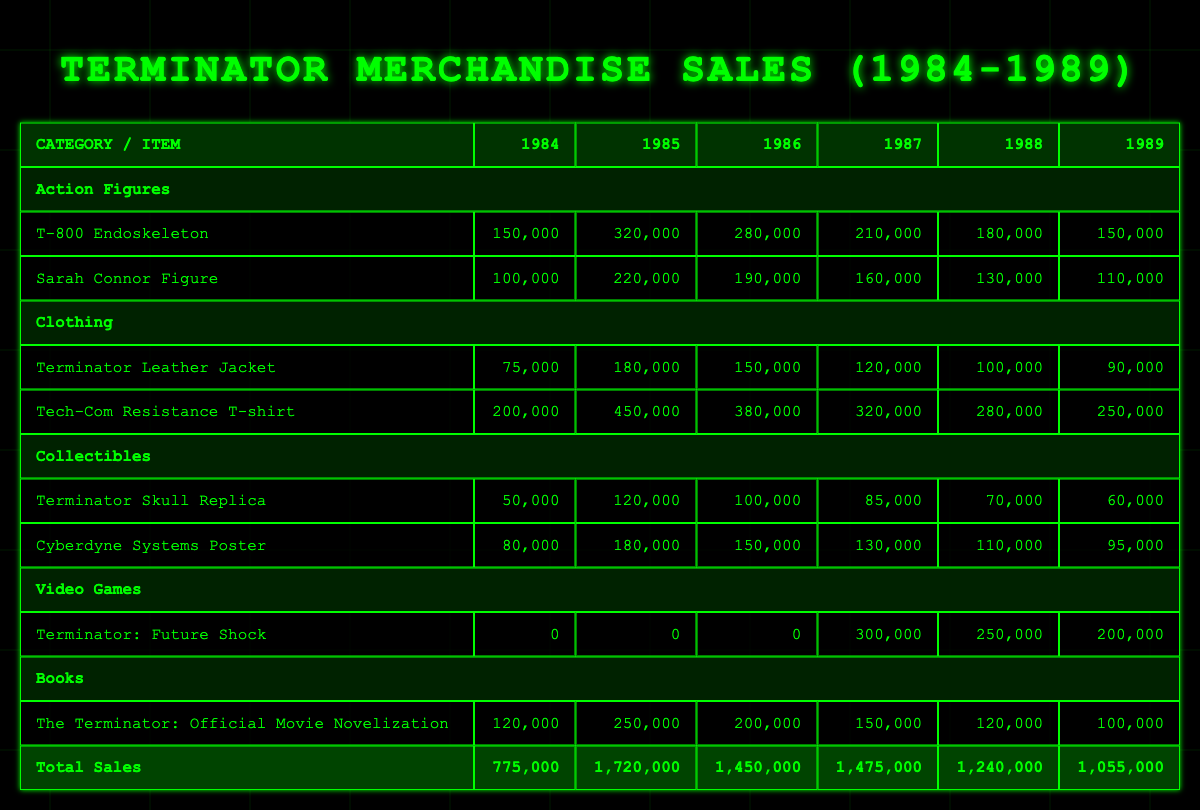What were the total sales for 1985? The total sales for 1985 can be found in the "Total Sales" row of the table. It shows 1,720,000 for that year.
Answer: 1,720,000 Which item had the highest sales in 1986? By examining the sales for each item in 1986, the "Tech-Com Resistance T-shirt" had the highest sales at 380,000.
Answer: Tech-Com Resistance T-shirt What is the difference in sales of the T-800 Endoskeleton between 1985 and 1989? The sales for the T-800 Endoskeleton in 1985 were 320,000, and in 1989 it was 150,000. The difference is 320,000 - 150,000 = 170,000.
Answer: 170,000 Did the sales of the Terminator Leather Jacket ever exceed 200,000? Checking the sales figures for the Terminator Leather Jacket, they all stay below 200,000, which confirms that the statement is false.
Answer: No What is the average sales of the Cyberdyne Systems Poster over the years? To find the average, sum the sales for each year: (80,000 + 180,000 + 150,000 + 130,000 + 110,000 + 95,000) = 745,000. Then divide by the number of years, which is 6: 745,000 / 6 = 124,166.67, rounded to 124,167.
Answer: 124,167 Which year showed the highest total merchandise sales? The highest total sales can be found in the "Total Sales" row. 1985 shows the maximum total sales at 1,720,000.
Answer: 1985 What are the total sales for action figures in 1987? By summarizing the sales for both action figures in 1987, T-800 Endoskeleton (210,000) + Sarah Connor Figure (160,000) gives a total of 370,000 for that category.
Answer: 370,000 Was the sales trend for the Tech-Com Resistance T-shirt increasing over its years? The sales for this item show an increase each year from 200,000 in 1984 to 450,000 in 1985 and continues to decrease after that, indicating the trend was not consistently increasing.
Answer: No How much did the sales of video games total from 1984 to 1989? The only video game listed is Terminator: Future Shock. Its total sales can be added together: 0 + 0 + 0 + 300,000 + 250,000 + 200,000 = 750,000.
Answer: 750,000 